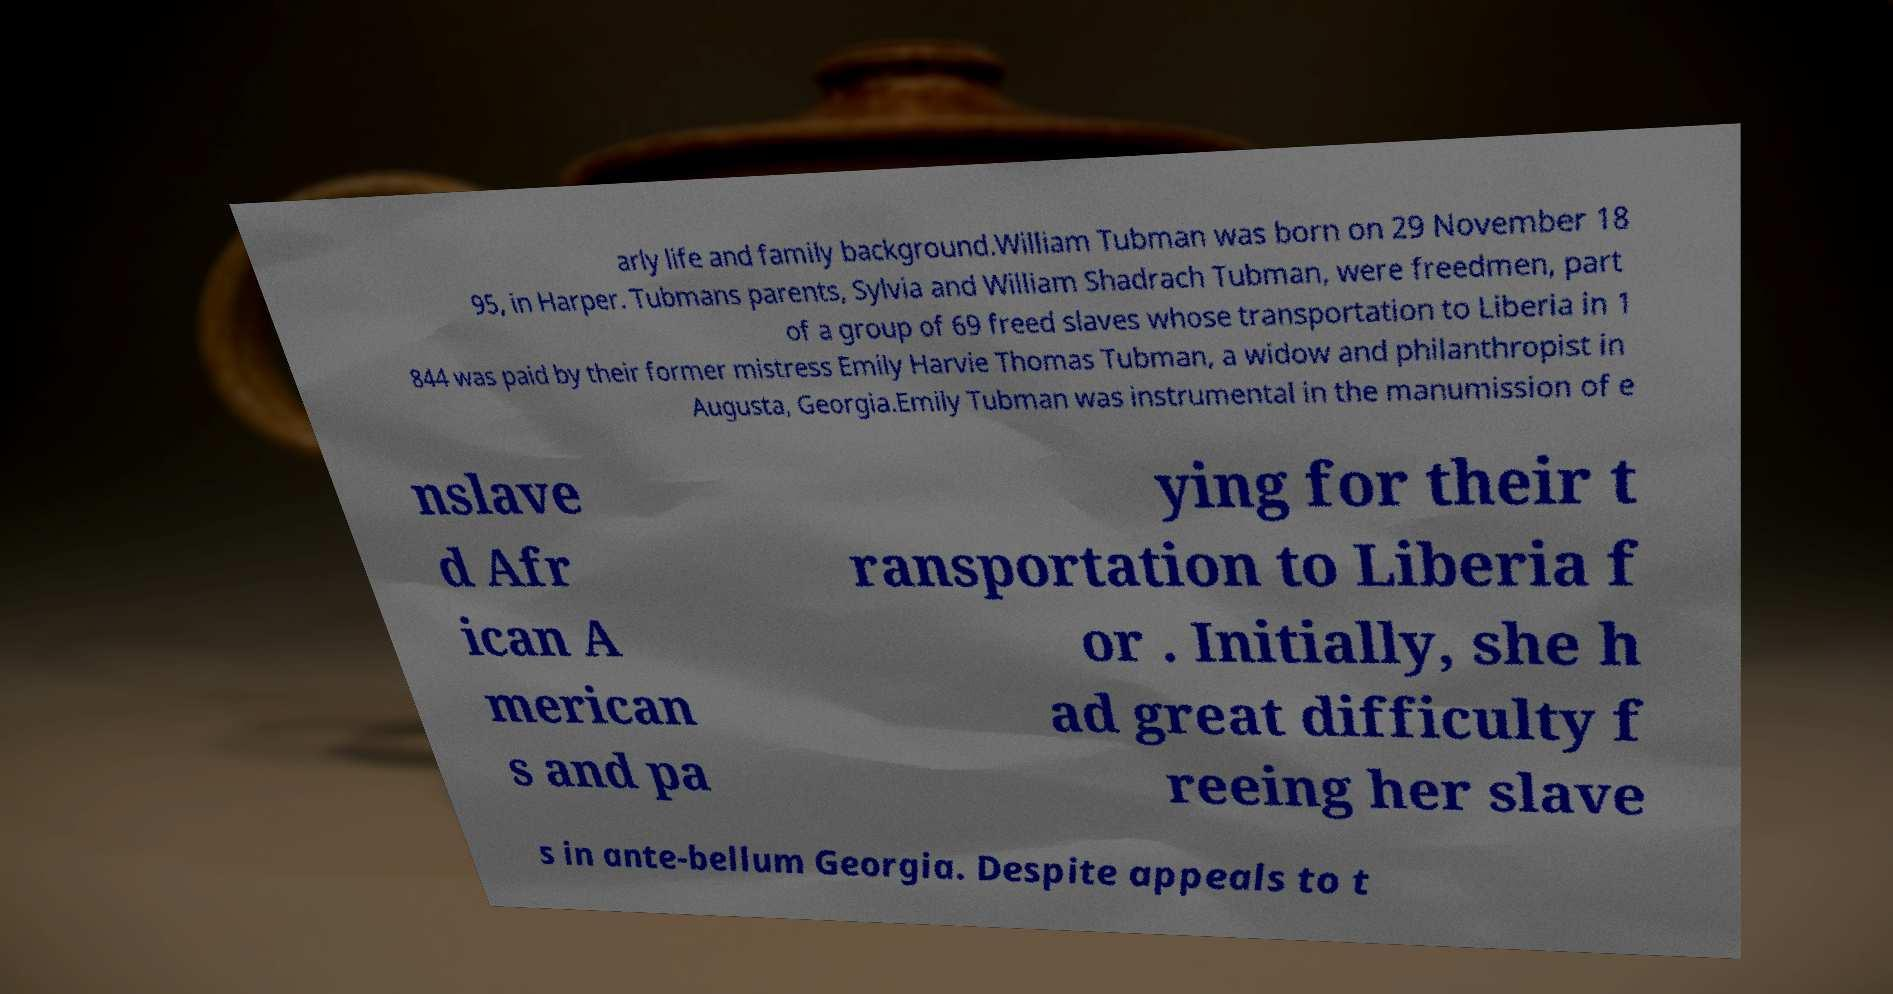Can you read and provide the text displayed in the image?This photo seems to have some interesting text. Can you extract and type it out for me? arly life and family background.William Tubman was born on 29 November 18 95, in Harper. Tubmans parents, Sylvia and William Shadrach Tubman, were freedmen, part of a group of 69 freed slaves whose transportation to Liberia in 1 844 was paid by their former mistress Emily Harvie Thomas Tubman, a widow and philanthropist in Augusta, Georgia.Emily Tubman was instrumental in the manumission of e nslave d Afr ican A merican s and pa ying for their t ransportation to Liberia f or . Initially, she h ad great difficulty f reeing her slave s in ante-bellum Georgia. Despite appeals to t 